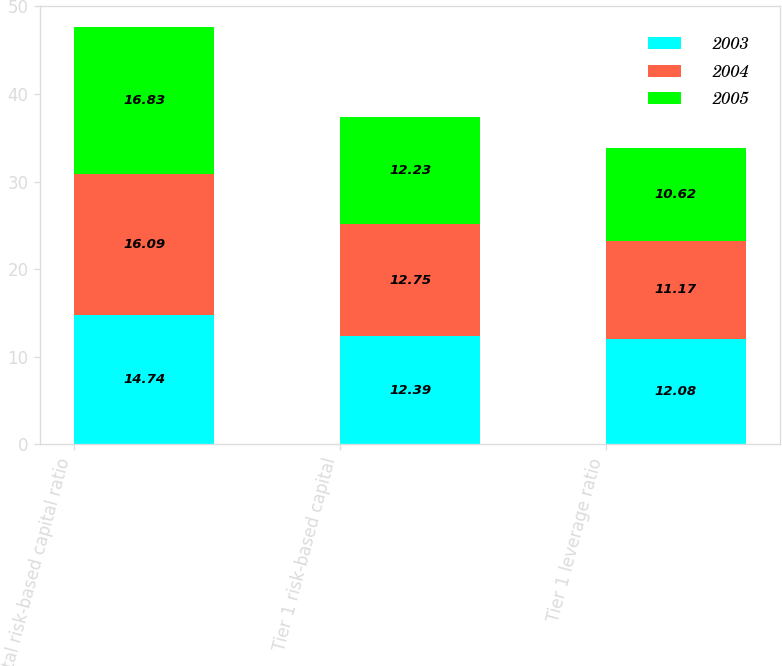<chart> <loc_0><loc_0><loc_500><loc_500><stacked_bar_chart><ecel><fcel>Total risk-based capital ratio<fcel>Tier 1 risk-based capital<fcel>Tier 1 leverage ratio<nl><fcel>2003<fcel>14.74<fcel>12.39<fcel>12.08<nl><fcel>2004<fcel>16.09<fcel>12.75<fcel>11.17<nl><fcel>2005<fcel>16.83<fcel>12.23<fcel>10.62<nl></chart> 